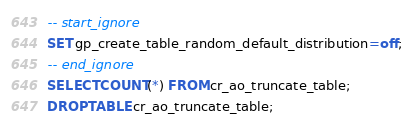<code> <loc_0><loc_0><loc_500><loc_500><_SQL_>-- start_ignore
SET gp_create_table_random_default_distribution=off;
-- end_ignore
SELECT COUNT(*) FROM cr_ao_truncate_table;
DROP TABLE cr_ao_truncate_table;
</code> 